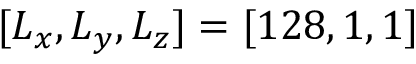Convert formula to latex. <formula><loc_0><loc_0><loc_500><loc_500>[ L _ { x } , L _ { y } , L _ { z } ] = [ 1 2 8 , 1 , 1 ]</formula> 